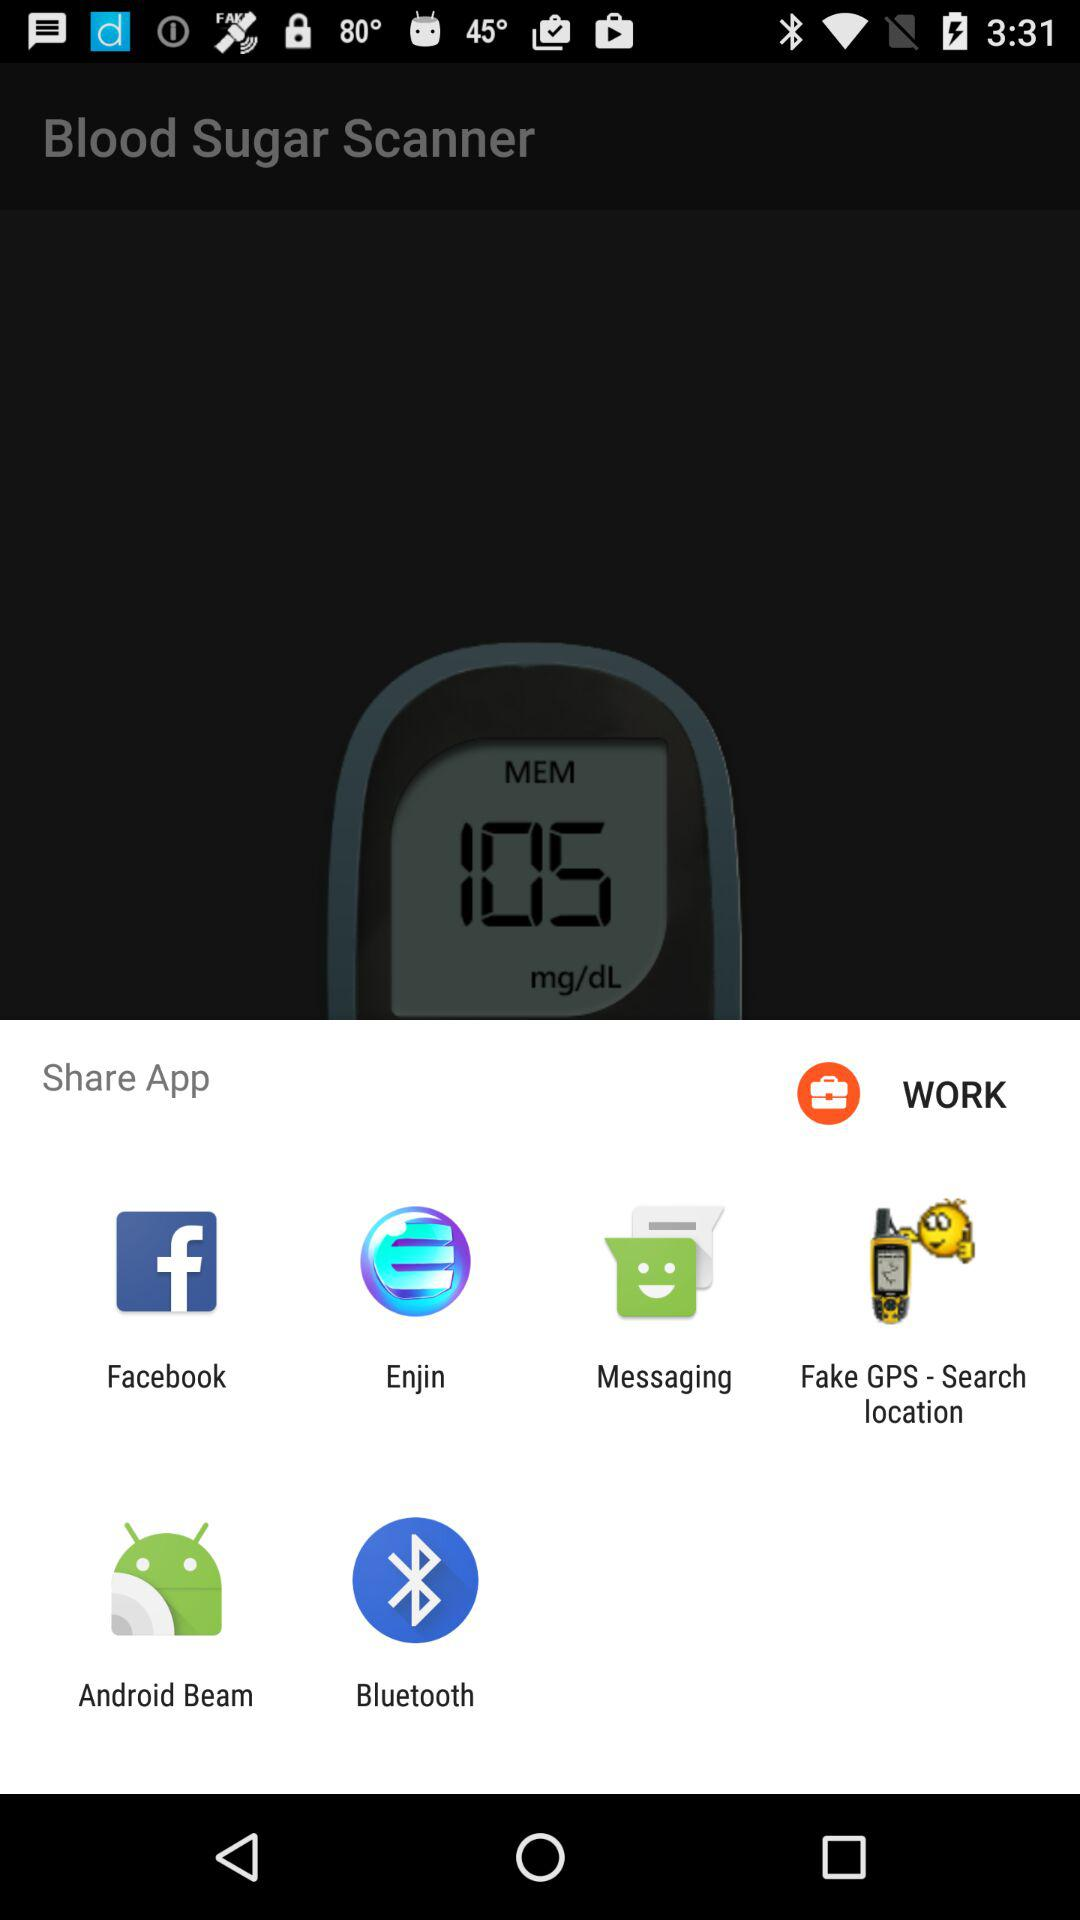Which applications can be used to share? The applications that can be used to share are "Facebook", "Enjin", "Messaging", "Fake GPS - Search location", "Android Beam" and "Bluetooth". 